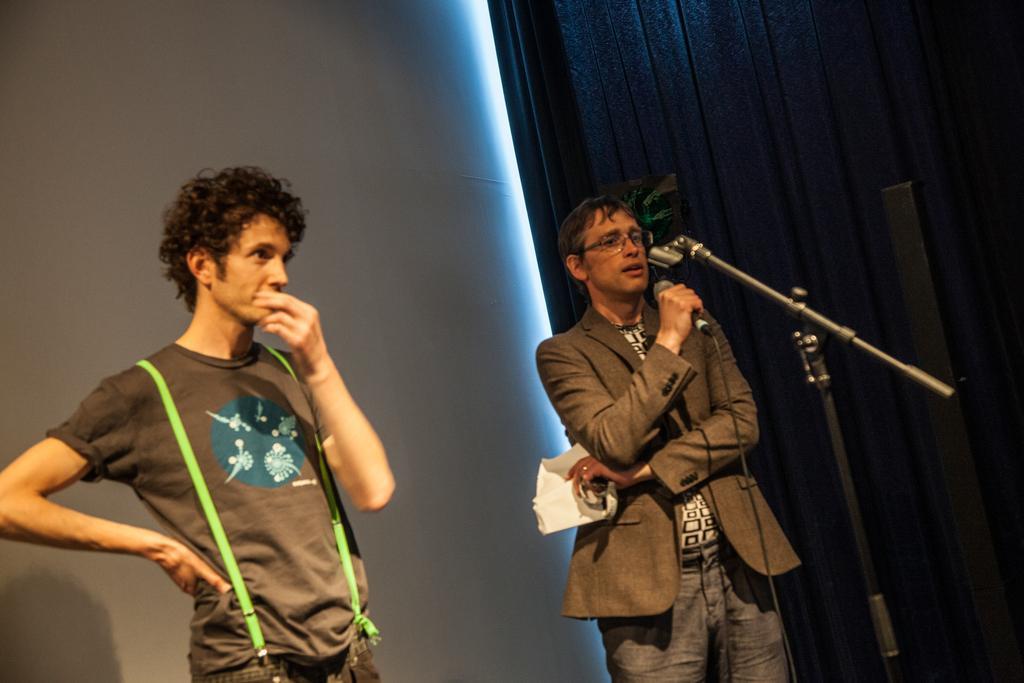In one or two sentences, can you explain what this image depicts? This picture is clicked inside the room. Here, we see two men standing. Man on the right corner of the picture is holding microphone in his hand and he is talking on it. Behind them, we see a white wall and beside him, we see a wall in brown color. 